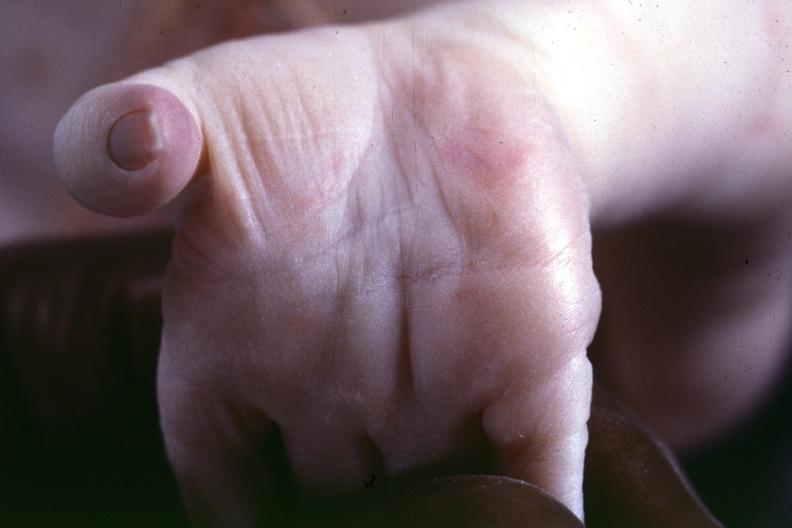what is present?
Answer the question using a single word or phrase. Palmar crease normal 